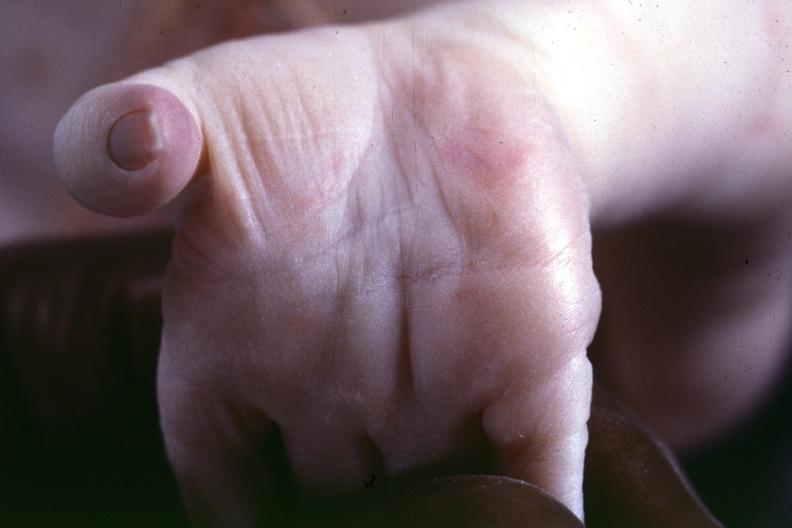what is present?
Answer the question using a single word or phrase. Palmar crease normal 